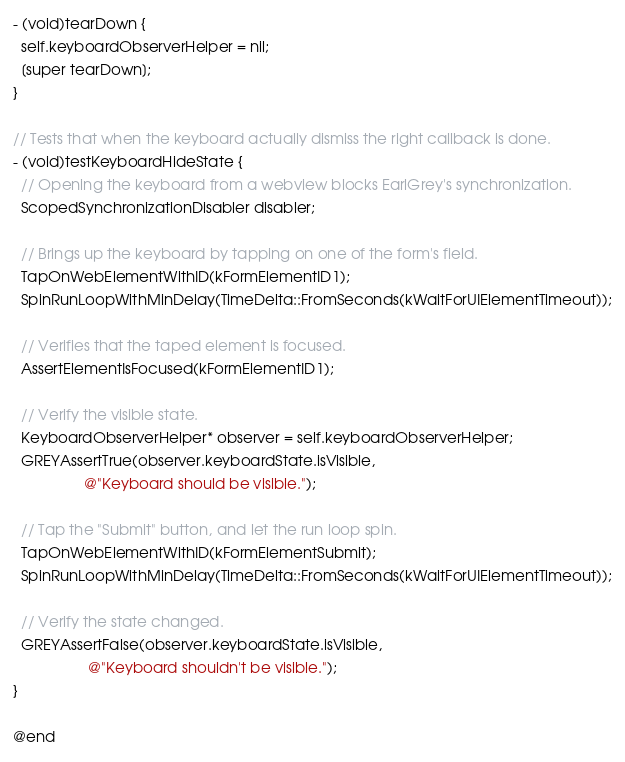<code> <loc_0><loc_0><loc_500><loc_500><_ObjectiveC_>
- (void)tearDown {
  self.keyboardObserverHelper = nil;
  [super tearDown];
}

// Tests that when the keyboard actually dismiss the right callback is done.
- (void)testKeyboardHideState {
  // Opening the keyboard from a webview blocks EarlGrey's synchronization.
  ScopedSynchronizationDisabler disabler;

  // Brings up the keyboard by tapping on one of the form's field.
  TapOnWebElementWithID(kFormElementID1);
  SpinRunLoopWithMinDelay(TimeDelta::FromSeconds(kWaitForUIElementTimeout));

  // Verifies that the taped element is focused.
  AssertElementIsFocused(kFormElementID1);

  // Verify the visible state.
  KeyboardObserverHelper* observer = self.keyboardObserverHelper;
  GREYAssertTrue(observer.keyboardState.isVisible,
                 @"Keyboard should be visible.");

  // Tap the "Submit" button, and let the run loop spin.
  TapOnWebElementWithID(kFormElementSubmit);
  SpinRunLoopWithMinDelay(TimeDelta::FromSeconds(kWaitForUIElementTimeout));

  // Verify the state changed.
  GREYAssertFalse(observer.keyboardState.isVisible,
                  @"Keyboard shouldn't be visible.");
}

@end
</code> 